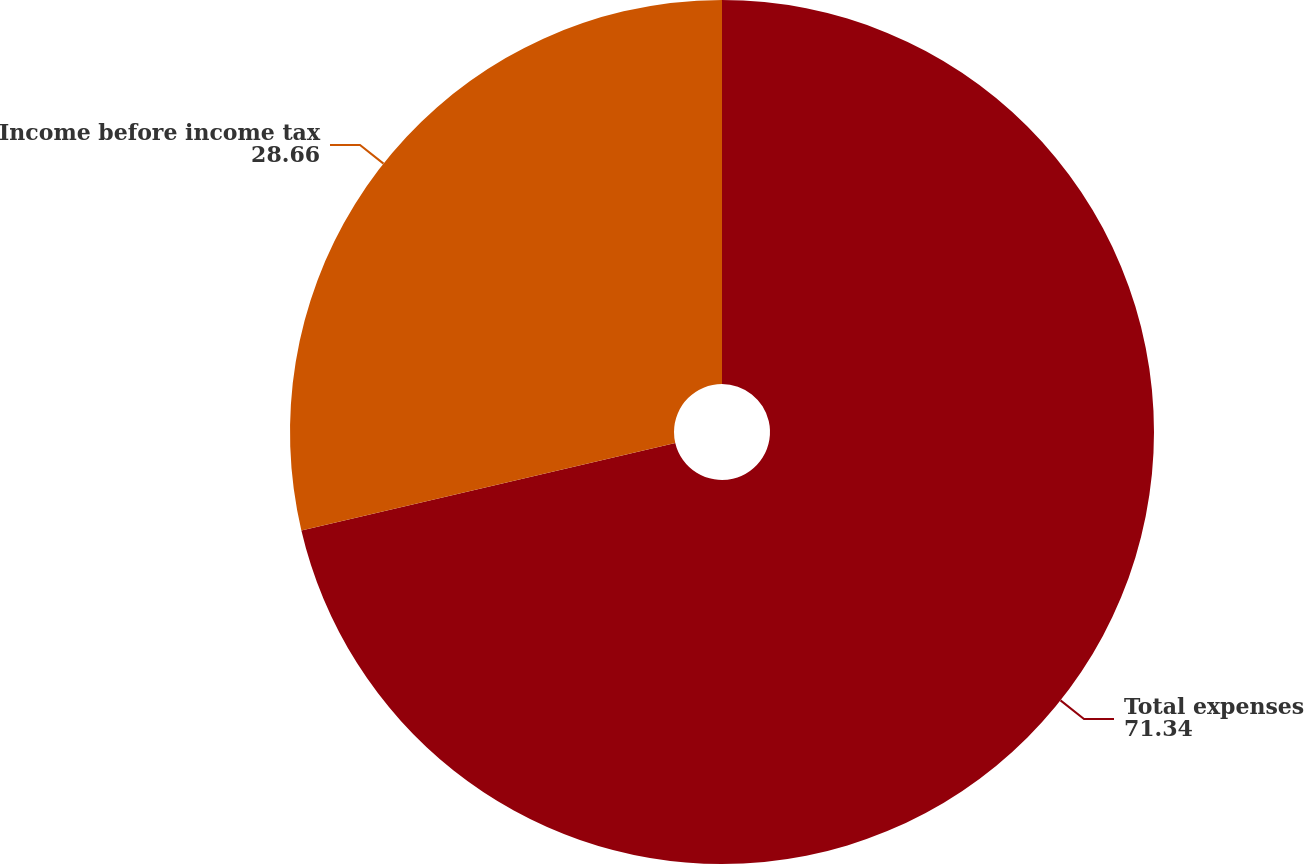<chart> <loc_0><loc_0><loc_500><loc_500><pie_chart><fcel>Total expenses<fcel>Income before income tax<nl><fcel>71.34%<fcel>28.66%<nl></chart> 